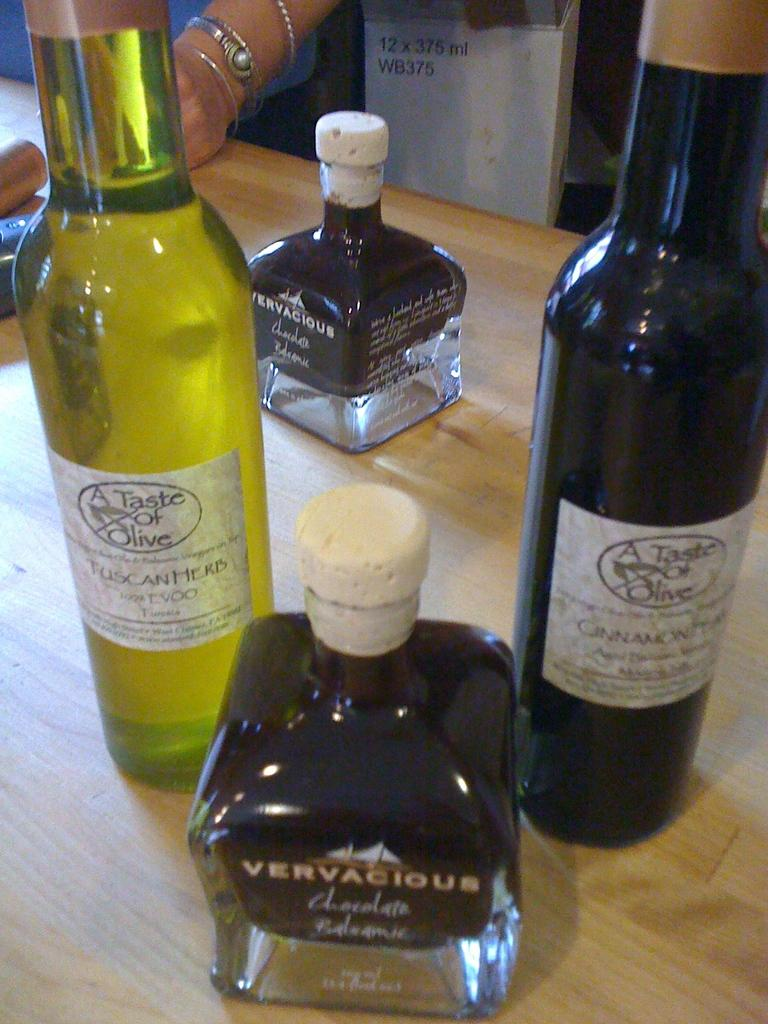<image>
Share a concise interpretation of the image provided. A bottle of Vervacious chocolate balsamic on a wooden table. 